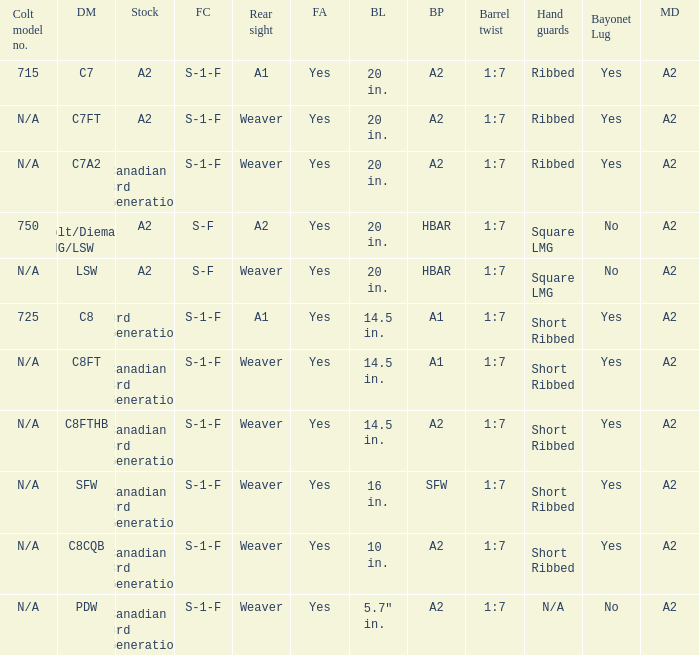Which Barrel twist has a Stock of canadian 3rd generation and a Hand guards of short ribbed? 1:7, 1:7, 1:7, 1:7. Give me the full table as a dictionary. {'header': ['Colt model no.', 'DM', 'Stock', 'FC', 'Rear sight', 'FA', 'BL', 'BP', 'Barrel twist', 'Hand guards', 'Bayonet Lug', 'MD'], 'rows': [['715', 'C7', 'A2', 'S-1-F', 'A1', 'Yes', '20 in.', 'A2', '1:7', 'Ribbed', 'Yes', 'A2'], ['N/A', 'C7FT', 'A2', 'S-1-F', 'Weaver', 'Yes', '20 in.', 'A2', '1:7', 'Ribbed', 'Yes', 'A2'], ['N/A', 'C7A2', 'Canadian 3rd Generation', 'S-1-F', 'Weaver', 'Yes', '20 in.', 'A2', '1:7', 'Ribbed', 'Yes', 'A2'], ['750', 'Colt/Diemaco LMG/LSW', 'A2', 'S-F', 'A2', 'Yes', '20 in.', 'HBAR', '1:7', 'Square LMG', 'No', 'A2'], ['N/A', 'LSW', 'A2', 'S-F', 'Weaver', 'Yes', '20 in.', 'HBAR', '1:7', 'Square LMG', 'No', 'A2'], ['725', 'C8', '3rd Generation', 'S-1-F', 'A1', 'Yes', '14.5 in.', 'A1', '1:7', 'Short Ribbed', 'Yes', 'A2'], ['N/A', 'C8FT', 'Canadian 3rd Generation', 'S-1-F', 'Weaver', 'Yes', '14.5 in.', 'A1', '1:7', 'Short Ribbed', 'Yes', 'A2'], ['N/A', 'C8FTHB', 'Canadian 3rd Generation', 'S-1-F', 'Weaver', 'Yes', '14.5 in.', 'A2', '1:7', 'Short Ribbed', 'Yes', 'A2'], ['N/A', 'SFW', 'Canadian 3rd Generation', 'S-1-F', 'Weaver', 'Yes', '16 in.', 'SFW', '1:7', 'Short Ribbed', 'Yes', 'A2'], ['N/A', 'C8CQB', 'Canadian 3rd Generation', 'S-1-F', 'Weaver', 'Yes', '10 in.', 'A2', '1:7', 'Short Ribbed', 'Yes', 'A2'], ['N/A', 'PDW', 'Canadian 3rd Generation', 'S-1-F', 'Weaver', 'Yes', '5.7" in.', 'A2', '1:7', 'N/A', 'No', 'A2']]} 